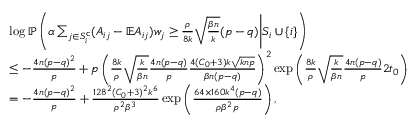<formula> <loc_0><loc_0><loc_500><loc_500>\begin{array} { r l } & { \log \mathbb { P } \left ( \alpha \sum _ { j \in S _ { i } ^ { c } } ( A _ { i j } - \mathbb { E } A _ { i j } ) w _ { j } \geq \frac { \rho } { 8 k } \sqrt { \frac { \beta n } { k } } ( p - q ) \Big | S _ { i } \cup \{ i \} \right ) } \\ & { \leq - \frac { 4 n ( p - q ) ^ { 2 } } { p } + p \left ( \frac { 8 k } { \rho } \sqrt { \frac { k } { \beta n } } \frac { 4 n ( p - q ) } { p } \frac { 4 ( C _ { 0 } + 3 ) k \sqrt { k n p } } { \beta n ( p - q ) } \right ) ^ { 2 } \exp \left ( \frac { 8 k } { \rho } \sqrt { \frac { k } { \beta n } } \frac { 4 n ( p - q ) } { p } 2 t _ { 0 } \right ) } \\ & { = - \frac { 4 n ( p - q ) ^ { 2 } } { p } + \frac { 1 2 8 ^ { 2 } ( C _ { 0 } + 3 ) ^ { 2 } k ^ { 6 } } { \rho ^ { 2 } \beta ^ { 3 } } \exp \left ( \frac { 6 4 \times 1 6 0 k ^ { 4 } ( p - q ) } { \rho \beta ^ { 2 } p } \right ) , } \end{array}</formula> 